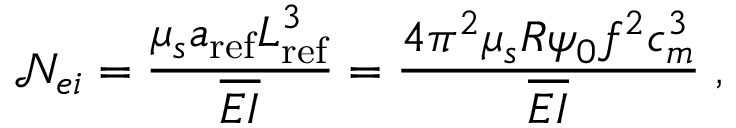Convert formula to latex. <formula><loc_0><loc_0><loc_500><loc_500>\mathcal { N } _ { e i } = \frac { \mu _ { s } a _ { r e f } L _ { r e f } ^ { 3 } } { \overline { E I } } = \frac { 4 \pi ^ { 2 } \mu _ { s } R \psi _ { 0 } f ^ { 2 } c _ { m } ^ { 3 } } { \overline { E I } } \, ,</formula> 